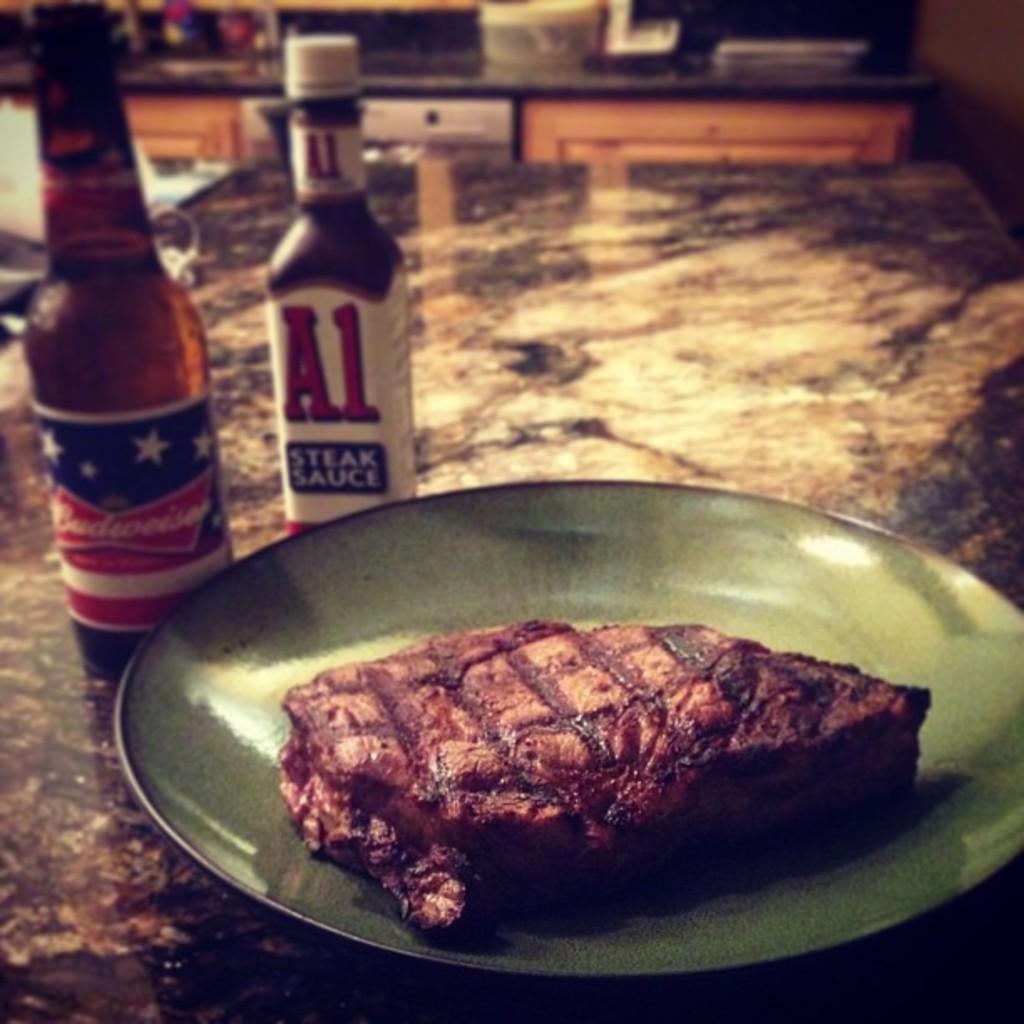What brand name is that beer?
Provide a short and direct response. Budweiser. 